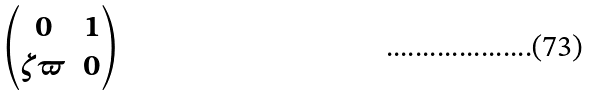<formula> <loc_0><loc_0><loc_500><loc_500>\begin{pmatrix} 0 & 1 \\ \zeta \varpi & 0 \end{pmatrix}</formula> 